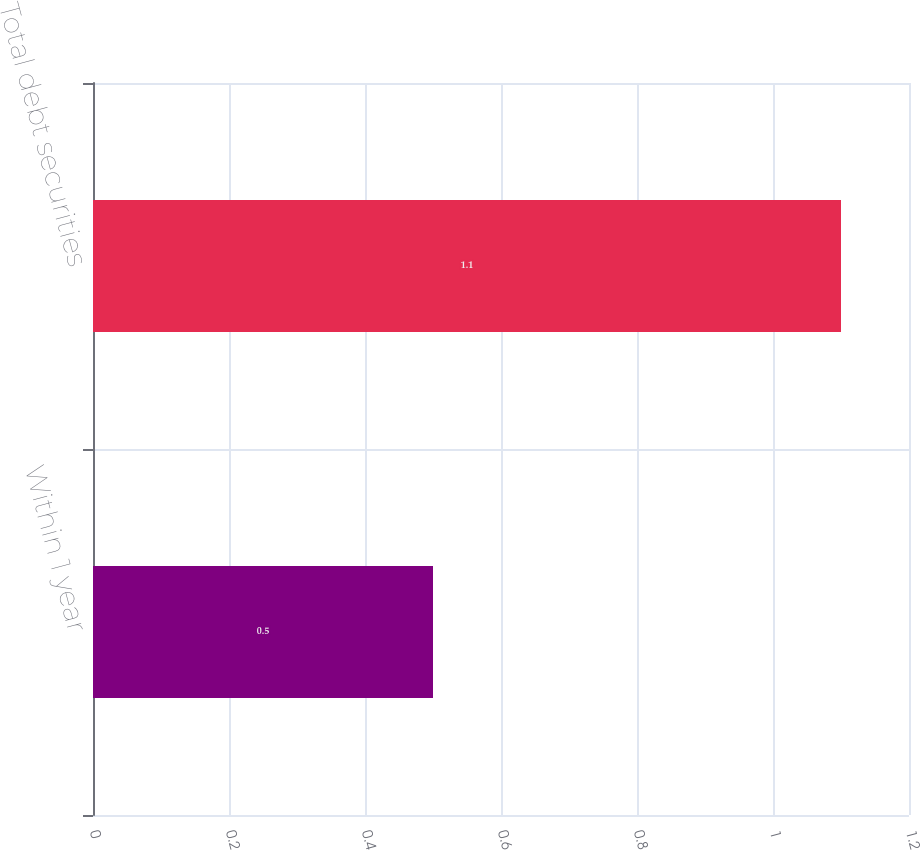<chart> <loc_0><loc_0><loc_500><loc_500><bar_chart><fcel>Within 1 year<fcel>Total debt securities<nl><fcel>0.5<fcel>1.1<nl></chart> 